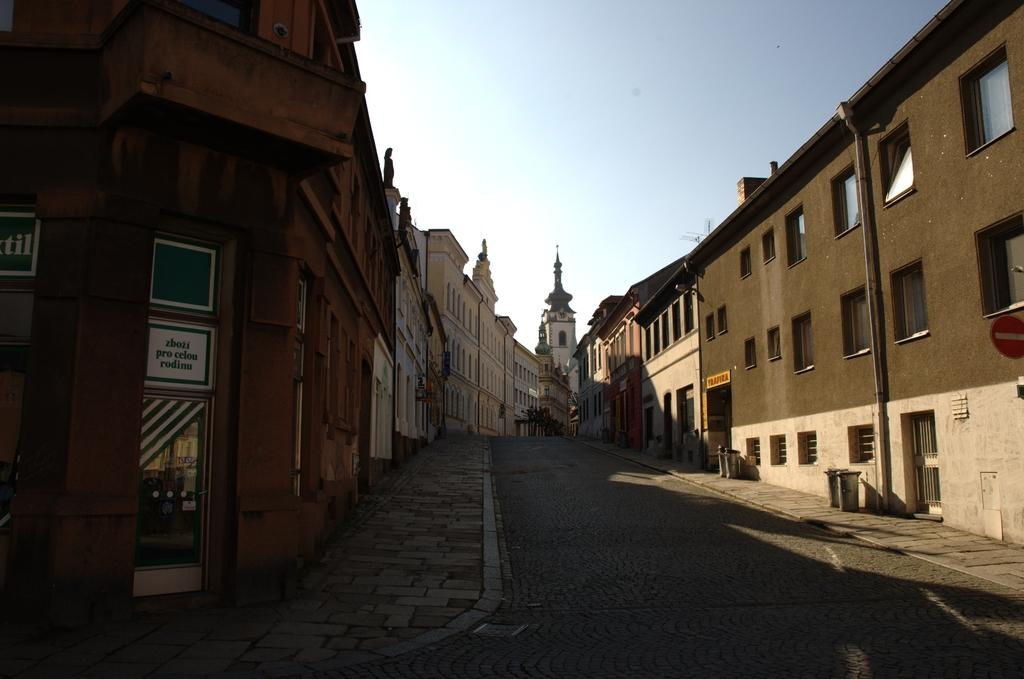What is the main subject in the foreground of the image? There is a street road in the foreground of the image. What structures are located near the street road? Buildings are present on either side of the street road. What can be seen at the top of the image? The sky is visible at the top of the image. What is the opinion of the toes in the image? There are no toes present in the image, so it is not possible to determine their opinion. 